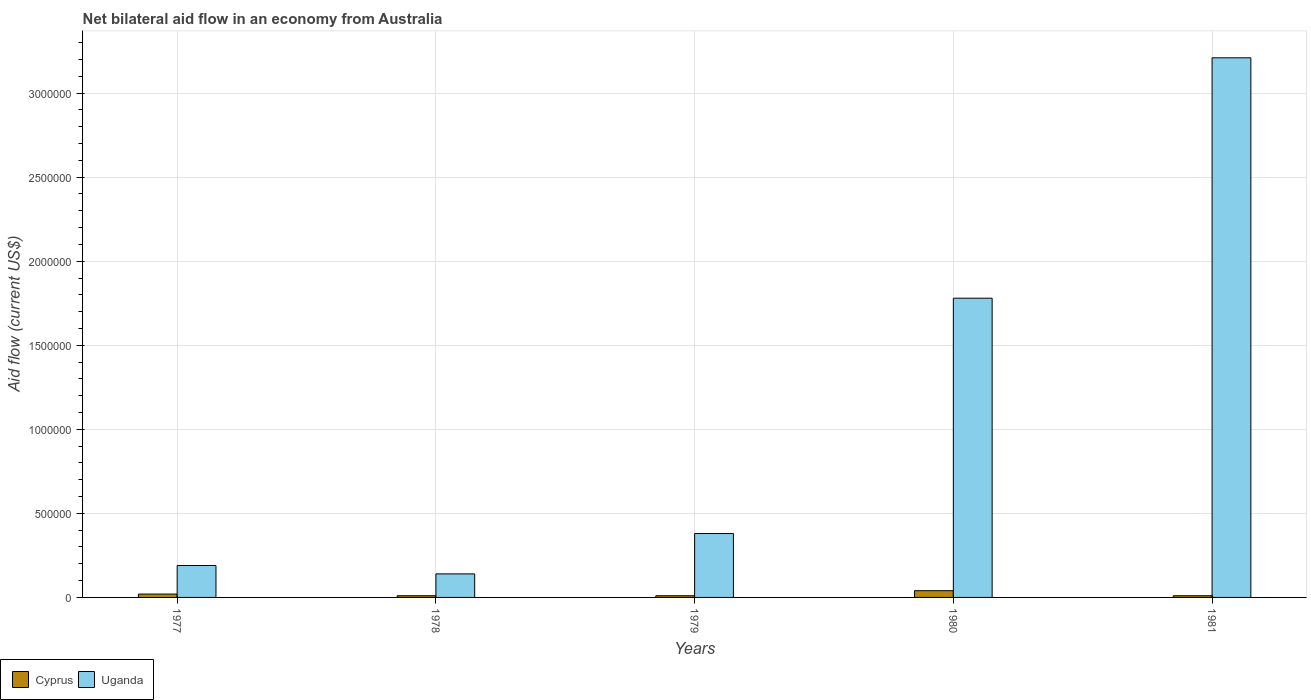How many groups of bars are there?
Keep it short and to the point. 5. Are the number of bars per tick equal to the number of legend labels?
Your response must be concise. Yes. Are the number of bars on each tick of the X-axis equal?
Your answer should be very brief. Yes. How many bars are there on the 1st tick from the right?
Provide a short and direct response. 2. What is the net bilateral aid flow in Uganda in 1978?
Make the answer very short. 1.40e+05. Across all years, what is the maximum net bilateral aid flow in Uganda?
Provide a short and direct response. 3.21e+06. Across all years, what is the minimum net bilateral aid flow in Uganda?
Ensure brevity in your answer.  1.40e+05. In which year was the net bilateral aid flow in Cyprus minimum?
Offer a very short reply. 1978. What is the difference between the net bilateral aid flow in Uganda in 1977 and that in 1981?
Your answer should be very brief. -3.02e+06. What is the difference between the net bilateral aid flow in Cyprus in 1978 and the net bilateral aid flow in Uganda in 1979?
Your response must be concise. -3.70e+05. What is the average net bilateral aid flow in Cyprus per year?
Keep it short and to the point. 1.80e+04. In the year 1981, what is the difference between the net bilateral aid flow in Cyprus and net bilateral aid flow in Uganda?
Offer a very short reply. -3.20e+06. In how many years, is the net bilateral aid flow in Cyprus greater than 3000000 US$?
Provide a succinct answer. 0. What is the ratio of the net bilateral aid flow in Uganda in 1979 to that in 1981?
Ensure brevity in your answer.  0.12. Is the net bilateral aid flow in Uganda in 1977 less than that in 1979?
Provide a short and direct response. Yes. What is the difference between the highest and the second highest net bilateral aid flow in Uganda?
Provide a succinct answer. 1.43e+06. In how many years, is the net bilateral aid flow in Uganda greater than the average net bilateral aid flow in Uganda taken over all years?
Your response must be concise. 2. Is the sum of the net bilateral aid flow in Uganda in 1977 and 1980 greater than the maximum net bilateral aid flow in Cyprus across all years?
Your answer should be very brief. Yes. What does the 1st bar from the left in 1981 represents?
Keep it short and to the point. Cyprus. What does the 1st bar from the right in 1981 represents?
Offer a very short reply. Uganda. How many years are there in the graph?
Your response must be concise. 5. Does the graph contain any zero values?
Offer a terse response. No. How are the legend labels stacked?
Provide a succinct answer. Horizontal. What is the title of the graph?
Keep it short and to the point. Net bilateral aid flow in an economy from Australia. Does "Bulgaria" appear as one of the legend labels in the graph?
Provide a succinct answer. No. What is the label or title of the X-axis?
Keep it short and to the point. Years. What is the label or title of the Y-axis?
Provide a succinct answer. Aid flow (current US$). What is the Aid flow (current US$) in Cyprus in 1977?
Make the answer very short. 2.00e+04. What is the Aid flow (current US$) in Uganda in 1978?
Provide a succinct answer. 1.40e+05. What is the Aid flow (current US$) of Uganda in 1980?
Your response must be concise. 1.78e+06. What is the Aid flow (current US$) in Uganda in 1981?
Keep it short and to the point. 3.21e+06. Across all years, what is the maximum Aid flow (current US$) in Uganda?
Give a very brief answer. 3.21e+06. Across all years, what is the minimum Aid flow (current US$) of Cyprus?
Make the answer very short. 10000. What is the total Aid flow (current US$) of Cyprus in the graph?
Offer a terse response. 9.00e+04. What is the total Aid flow (current US$) in Uganda in the graph?
Ensure brevity in your answer.  5.70e+06. What is the difference between the Aid flow (current US$) of Cyprus in 1977 and that in 1978?
Your answer should be very brief. 10000. What is the difference between the Aid flow (current US$) in Uganda in 1977 and that in 1978?
Ensure brevity in your answer.  5.00e+04. What is the difference between the Aid flow (current US$) in Uganda in 1977 and that in 1979?
Your answer should be compact. -1.90e+05. What is the difference between the Aid flow (current US$) in Uganda in 1977 and that in 1980?
Your answer should be very brief. -1.59e+06. What is the difference between the Aid flow (current US$) of Uganda in 1977 and that in 1981?
Ensure brevity in your answer.  -3.02e+06. What is the difference between the Aid flow (current US$) of Cyprus in 1978 and that in 1979?
Keep it short and to the point. 0. What is the difference between the Aid flow (current US$) of Uganda in 1978 and that in 1980?
Your answer should be compact. -1.64e+06. What is the difference between the Aid flow (current US$) in Uganda in 1978 and that in 1981?
Provide a short and direct response. -3.07e+06. What is the difference between the Aid flow (current US$) of Uganda in 1979 and that in 1980?
Provide a short and direct response. -1.40e+06. What is the difference between the Aid flow (current US$) of Cyprus in 1979 and that in 1981?
Provide a short and direct response. 0. What is the difference between the Aid flow (current US$) of Uganda in 1979 and that in 1981?
Your answer should be very brief. -2.83e+06. What is the difference between the Aid flow (current US$) of Uganda in 1980 and that in 1981?
Your answer should be very brief. -1.43e+06. What is the difference between the Aid flow (current US$) in Cyprus in 1977 and the Aid flow (current US$) in Uganda in 1978?
Keep it short and to the point. -1.20e+05. What is the difference between the Aid flow (current US$) of Cyprus in 1977 and the Aid flow (current US$) of Uganda in 1979?
Keep it short and to the point. -3.60e+05. What is the difference between the Aid flow (current US$) of Cyprus in 1977 and the Aid flow (current US$) of Uganda in 1980?
Your answer should be very brief. -1.76e+06. What is the difference between the Aid flow (current US$) of Cyprus in 1977 and the Aid flow (current US$) of Uganda in 1981?
Offer a terse response. -3.19e+06. What is the difference between the Aid flow (current US$) of Cyprus in 1978 and the Aid flow (current US$) of Uganda in 1979?
Your response must be concise. -3.70e+05. What is the difference between the Aid flow (current US$) of Cyprus in 1978 and the Aid flow (current US$) of Uganda in 1980?
Give a very brief answer. -1.77e+06. What is the difference between the Aid flow (current US$) of Cyprus in 1978 and the Aid flow (current US$) of Uganda in 1981?
Offer a very short reply. -3.20e+06. What is the difference between the Aid flow (current US$) of Cyprus in 1979 and the Aid flow (current US$) of Uganda in 1980?
Offer a terse response. -1.77e+06. What is the difference between the Aid flow (current US$) of Cyprus in 1979 and the Aid flow (current US$) of Uganda in 1981?
Give a very brief answer. -3.20e+06. What is the difference between the Aid flow (current US$) of Cyprus in 1980 and the Aid flow (current US$) of Uganda in 1981?
Provide a short and direct response. -3.17e+06. What is the average Aid flow (current US$) in Cyprus per year?
Make the answer very short. 1.80e+04. What is the average Aid flow (current US$) in Uganda per year?
Make the answer very short. 1.14e+06. In the year 1979, what is the difference between the Aid flow (current US$) of Cyprus and Aid flow (current US$) of Uganda?
Ensure brevity in your answer.  -3.70e+05. In the year 1980, what is the difference between the Aid flow (current US$) of Cyprus and Aid flow (current US$) of Uganda?
Ensure brevity in your answer.  -1.74e+06. In the year 1981, what is the difference between the Aid flow (current US$) in Cyprus and Aid flow (current US$) in Uganda?
Give a very brief answer. -3.20e+06. What is the ratio of the Aid flow (current US$) in Cyprus in 1977 to that in 1978?
Provide a succinct answer. 2. What is the ratio of the Aid flow (current US$) of Uganda in 1977 to that in 1978?
Offer a very short reply. 1.36. What is the ratio of the Aid flow (current US$) in Cyprus in 1977 to that in 1979?
Your answer should be very brief. 2. What is the ratio of the Aid flow (current US$) in Uganda in 1977 to that in 1980?
Your response must be concise. 0.11. What is the ratio of the Aid flow (current US$) in Cyprus in 1977 to that in 1981?
Provide a short and direct response. 2. What is the ratio of the Aid flow (current US$) of Uganda in 1977 to that in 1981?
Offer a very short reply. 0.06. What is the ratio of the Aid flow (current US$) in Uganda in 1978 to that in 1979?
Offer a very short reply. 0.37. What is the ratio of the Aid flow (current US$) in Cyprus in 1978 to that in 1980?
Keep it short and to the point. 0.25. What is the ratio of the Aid flow (current US$) in Uganda in 1978 to that in 1980?
Provide a succinct answer. 0.08. What is the ratio of the Aid flow (current US$) of Uganda in 1978 to that in 1981?
Ensure brevity in your answer.  0.04. What is the ratio of the Aid flow (current US$) of Uganda in 1979 to that in 1980?
Ensure brevity in your answer.  0.21. What is the ratio of the Aid flow (current US$) in Uganda in 1979 to that in 1981?
Provide a short and direct response. 0.12. What is the ratio of the Aid flow (current US$) in Uganda in 1980 to that in 1981?
Make the answer very short. 0.55. What is the difference between the highest and the second highest Aid flow (current US$) of Cyprus?
Give a very brief answer. 2.00e+04. What is the difference between the highest and the second highest Aid flow (current US$) of Uganda?
Make the answer very short. 1.43e+06. What is the difference between the highest and the lowest Aid flow (current US$) in Uganda?
Offer a very short reply. 3.07e+06. 